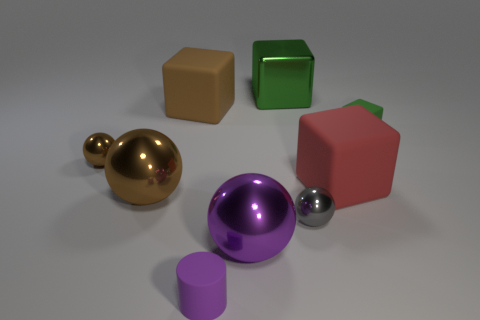The object that is the same color as the metallic block is what size?
Give a very brief answer. Small. Do the small matte cube and the large shiny cube have the same color?
Offer a very short reply. Yes. There is a thing that is the same color as the tiny cube; what is its shape?
Your answer should be compact. Cube. Is the shape of the big rubber thing that is on the left side of the purple metal thing the same as the big rubber object that is in front of the tiny brown sphere?
Give a very brief answer. Yes. Is there a small green block behind the small shiny sphere that is right of the tiny brown metal ball?
Provide a succinct answer. Yes. Is there a metal cube?
Offer a terse response. Yes. How many brown balls have the same size as the green metallic object?
Your answer should be very brief. 1. What number of things are both to the right of the large red object and in front of the small brown shiny thing?
Give a very brief answer. 0. There is a metallic thing on the right side of the green metallic cube; is its size the same as the large red rubber block?
Make the answer very short. No. Are there any other tiny cubes that have the same color as the metal block?
Your response must be concise. Yes. 